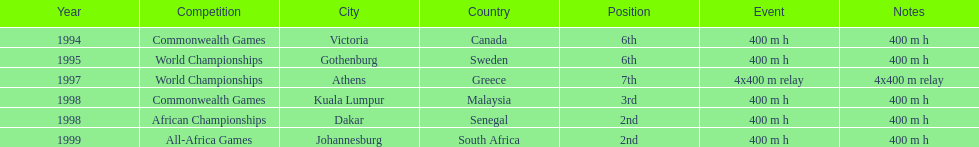How long was the relay at the 1997 world championships that ken harden ran 4x400 m relay. 